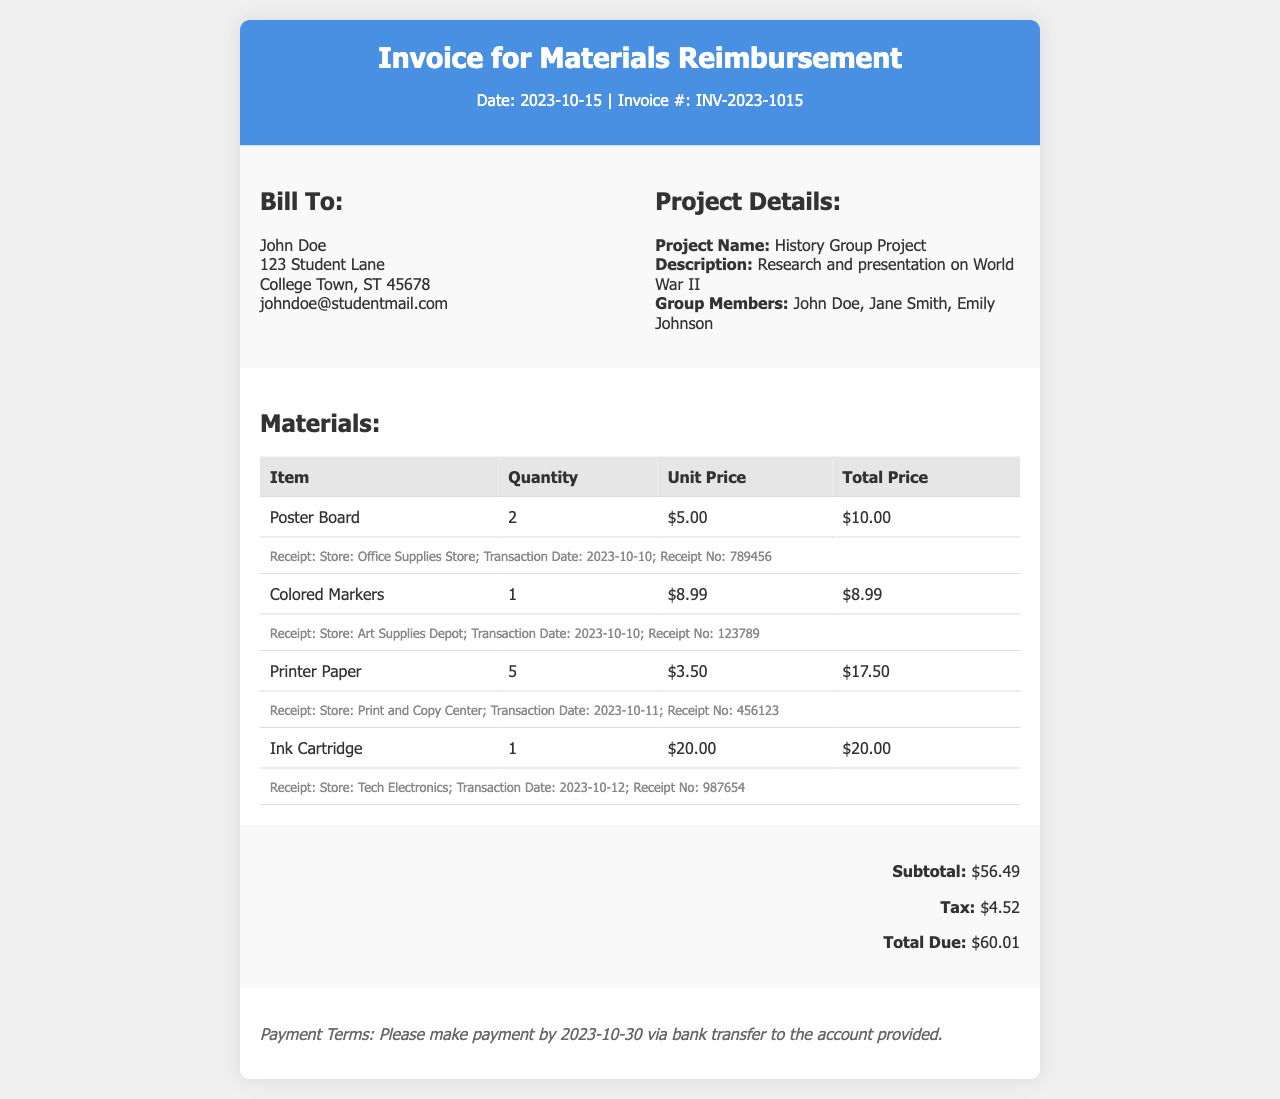what is the invoice number? The invoice number is directly listed in the document header as INV-2023-1015.
Answer: INV-2023-1015 who is the bill to? The bill to section provides the name of the individual who will receive the invoice, which is John Doe.
Answer: John Doe what is the total due amount? The total due is calculated as subtotal plus tax, which is $60.01.
Answer: $60.01 how many colored markers were purchased? The quantity of colored markers purchased is explicitly stated in the materials list as 1.
Answer: 1 what is the project name? The project name is included in the project details section and is identified as "History Group Project."
Answer: History Group Project when is the payment due by? The payment terms section specifies that payment is due by October 30, 2023.
Answer: 2023-10-30 how much did the poster board cost? The total price for poster boards is given in the materials table as $10.00.
Answer: $10.00 what store was the printer paper receipt from? The receipt information indicates the store for printer paper as "Print and Copy Center."
Answer: Print and Copy Center what are the group members' names? The document lists the group members' names: John Doe, Jane Smith, and Emily Johnson.
Answer: John Doe, Jane Smith, Emily Johnson 